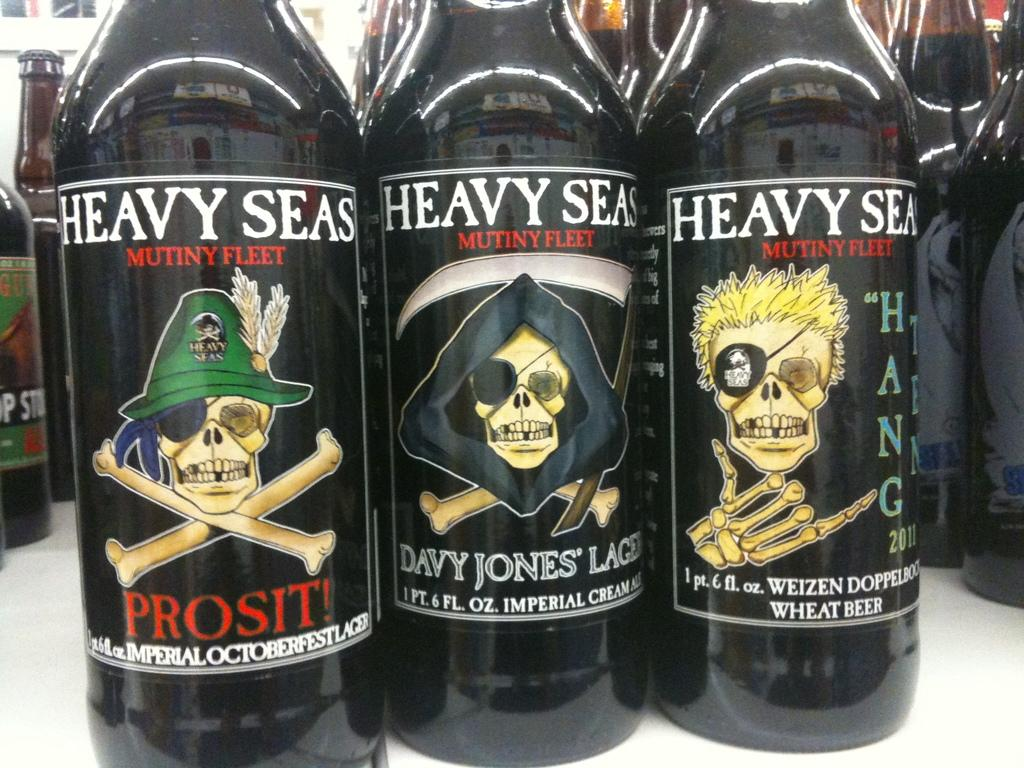Provide a one-sentence caption for the provided image. Three black Heavy Seas beer bottles placed next to each other. 